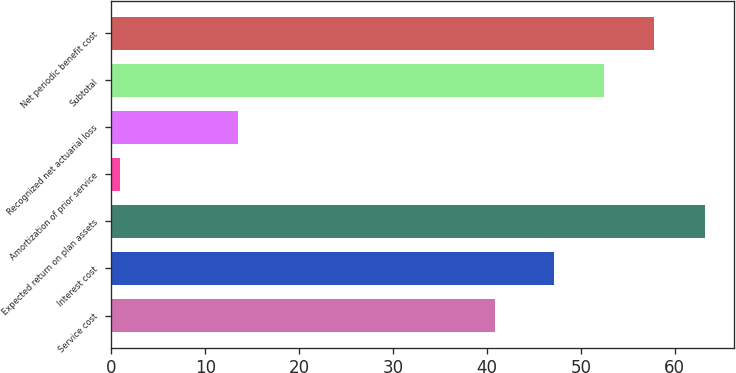<chart> <loc_0><loc_0><loc_500><loc_500><bar_chart><fcel>Service cost<fcel>Interest cost<fcel>Expected return on plan assets<fcel>Amortization of prior service<fcel>Recognized net actuarial loss<fcel>Subtotal<fcel>Net periodic benefit cost<nl><fcel>40.9<fcel>47.1<fcel>63.18<fcel>0.9<fcel>13.5<fcel>52.46<fcel>57.82<nl></chart> 